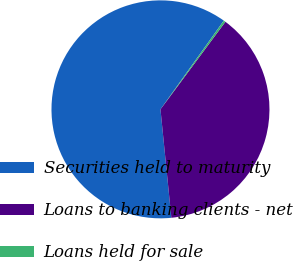Convert chart to OTSL. <chart><loc_0><loc_0><loc_500><loc_500><pie_chart><fcel>Securities held to maturity<fcel>Loans to banking clients - net<fcel>Loans held for sale<nl><fcel>61.46%<fcel>38.25%<fcel>0.29%<nl></chart> 